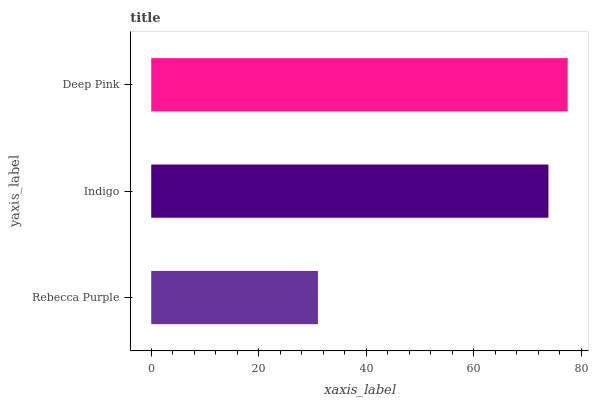Is Rebecca Purple the minimum?
Answer yes or no. Yes. Is Deep Pink the maximum?
Answer yes or no. Yes. Is Indigo the minimum?
Answer yes or no. No. Is Indigo the maximum?
Answer yes or no. No. Is Indigo greater than Rebecca Purple?
Answer yes or no. Yes. Is Rebecca Purple less than Indigo?
Answer yes or no. Yes. Is Rebecca Purple greater than Indigo?
Answer yes or no. No. Is Indigo less than Rebecca Purple?
Answer yes or no. No. Is Indigo the high median?
Answer yes or no. Yes. Is Indigo the low median?
Answer yes or no. Yes. Is Rebecca Purple the high median?
Answer yes or no. No. Is Deep Pink the low median?
Answer yes or no. No. 